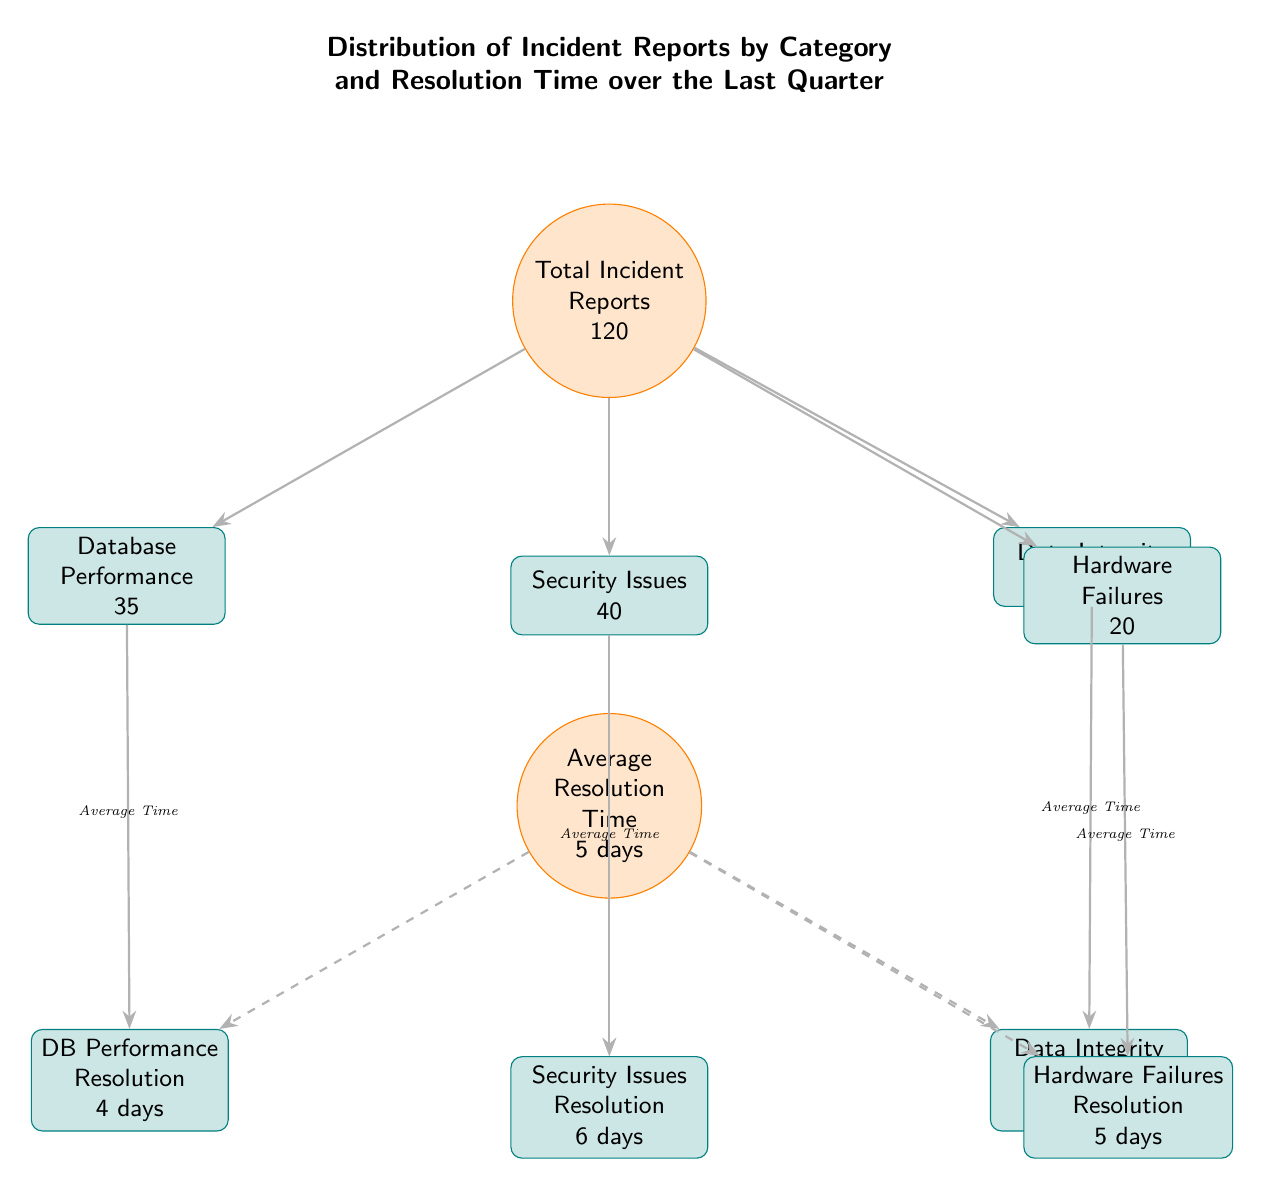What is the total number of incident reports? The diagram shows a main circular node labeled "Total Incident Reports" with the value 120 inside it, which represents the total count of incident reports.
Answer: 120 How many categories of incident reports are there? The diagram displays four boxes beneath the total incident reports, each representing a different category of incident reports. Counting these boxes, there are four categories shown.
Answer: 4 What is the average resolution time for "Security Issues"? The diagram has a box labeled "Security Issues Resolution" below the "Average Resolution Time" circle, and it shows "6 days." This indicates the average time taken to resolve security issues.
Answer: 6 days Which category has the highest number of incident reports? By examining the boxes beneath total incident reports, "Security Issues" has the highest value at 40 compared to other categories, indicating it has the most reports.
Answer: Security Issues What is the average resolution time for "Database Performance"? The box labeled "DB Performance Resolution" shows a resolution time of "4 days," which indicates how long it typically takes to resolve issues in this category.
Answer: 4 days How does the resolution time for "Data Integrity" compare to "Hardware Failures"? The box for "Data Integrity Resolution" shows "5 days," while "Hardware Failures Resolution" also shows "5 days," indicating that both categories have the same average resolution time.
Answer: 5 days Which incident category has the least reports? The box for "Data Integrity" indicates a total of 25 reports, which is the smallest number among all categories displayed in the diagram.
Answer: Data Integrity What is the average resolution time for the total incident reports? The average resolution time for all categories shown in the diagram is indicated by the node "Average Resolution Time" which shows "5 days." This represents the central resolution metric across categories.
Answer: 5 days What is the relationship between "Total Incident Reports" and its categories? The arrows from "Total Incident Reports" to each of the category boxes show a direct flow of information, indicating that each category is a subset of the total incident reports.
Answer: Subset relationship 